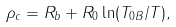<formula> <loc_0><loc_0><loc_500><loc_500>\rho _ { c } = R _ { b } + R _ { 0 } \ln ( T _ { 0 B } / T ) ,</formula> 